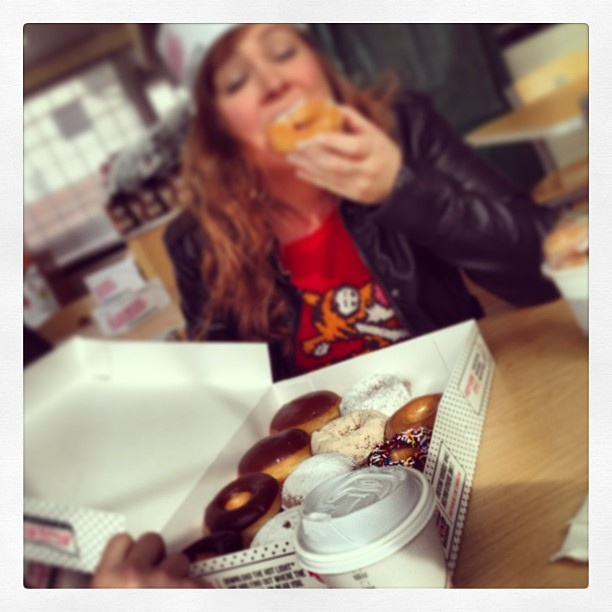Describe the objects in this image and their specific colors. I can see people in white, black, maroon, tan, and brown tones, dining table in whitesmoke, tan, gray, and brown tones, cup in whitesmoke, beige, darkgray, lightgray, and gray tones, donut in whitesmoke, beige, maroon, and darkgray tones, and people in whitesmoke, maroon, brown, and salmon tones in this image. 